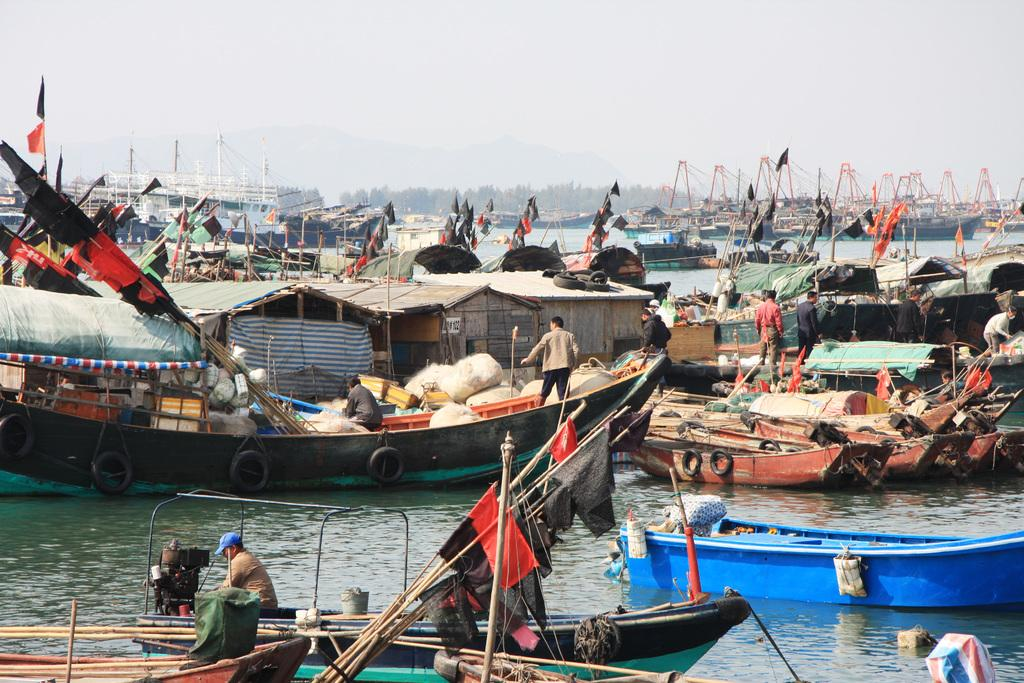What can be seen in the image related to water transportation? There are multiple boats in the image. Are there any people on the boats? Yes, there are people in at least one of the boats. What else can be found in the boats? There are various objects in the boats. What is the natural setting in the image? There is water in the image, and the sky is visible at the top. What type of jelly can be seen floating in the water in the image? There is no jelly present in the image; it features multiple boats on water. How many matches are visible in the image? There are no matches present in the image. 